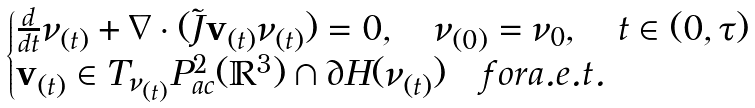<formula> <loc_0><loc_0><loc_500><loc_500>\begin{cases} \frac { d } { d t } \nu _ { ( t ) } + \nabla \cdot ( \tilde { J } \mathbf v _ { ( t ) } \nu _ { ( t ) } ) = 0 , \quad \nu _ { ( 0 ) } = \nu _ { 0 } , \quad t \in ( 0 , \tau ) \\ \mathbf v _ { ( t ) } \in T _ { \nu _ { ( t ) } } P _ { a c } ^ { 2 } ( \mathbb { R } ^ { 3 } ) \cap \partial H ( \nu _ { ( t ) } ) \quad f o r a . e . t . \end{cases}</formula> 